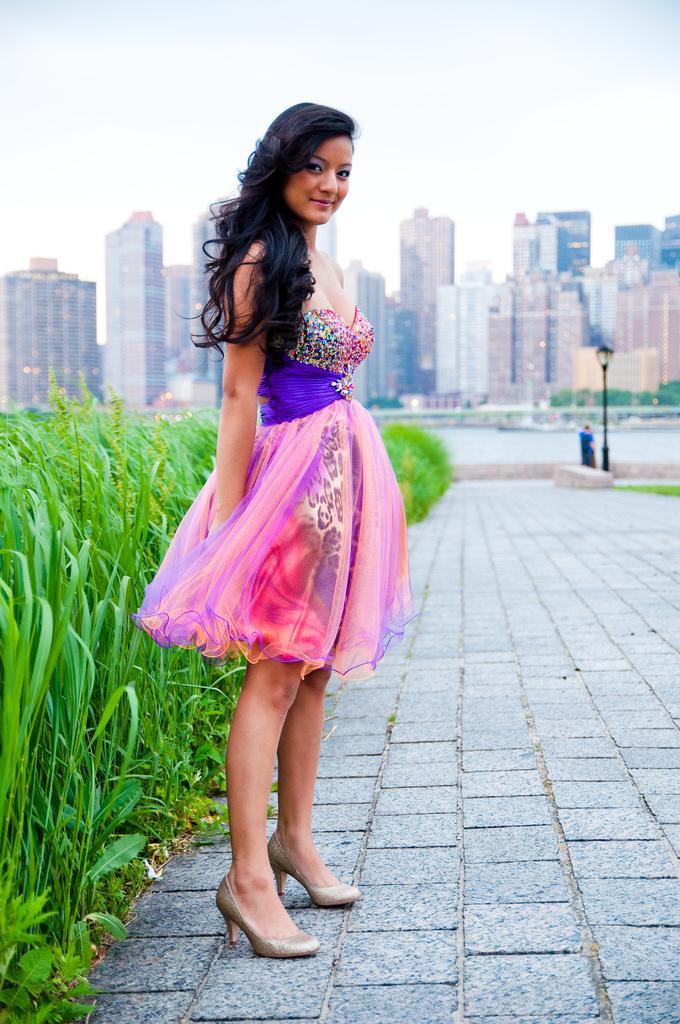Could you give a brief overview of what you see in this image? This image is taken outdoors. At the bottom of the image there is a floor. On the left side of the image there are a few plants. In the middle of the image a woman is standing on the floor. In the background there are many buildings and skyscrapers. At the top of the image there is a sky with clouds. On the right side of the image there is a street light and a man is standing on the floor. 